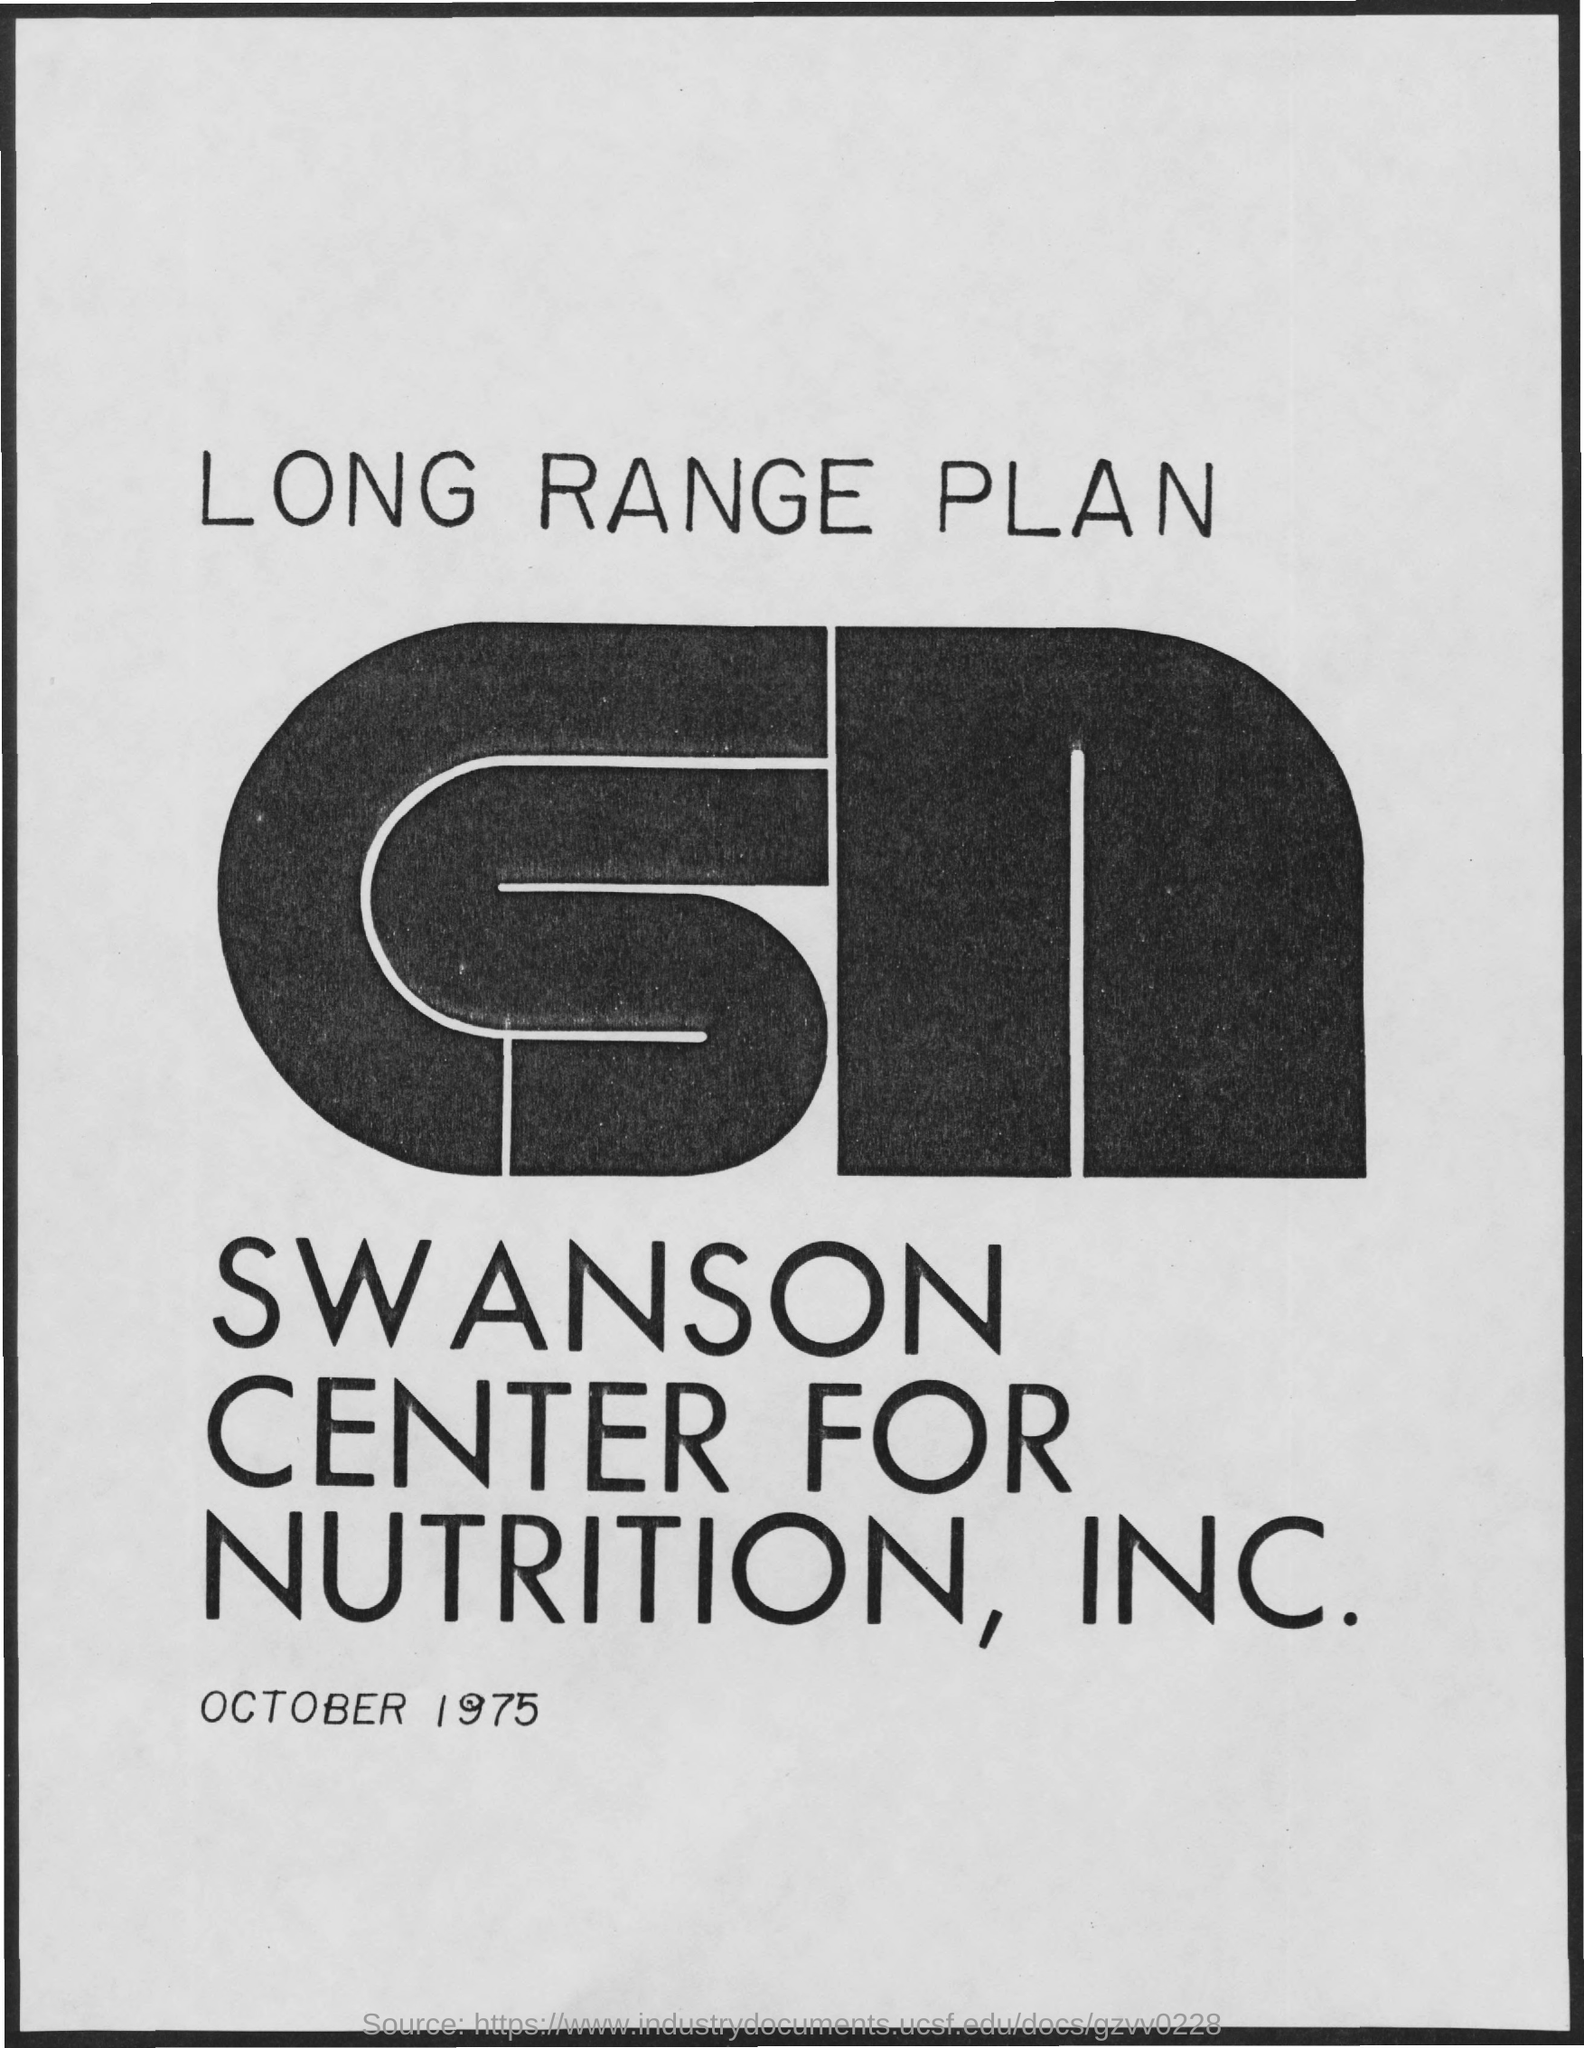What is the Title of the document?
Make the answer very short. Long Range Plan. What is the date on the document?
Provide a succinct answer. October 1975. 